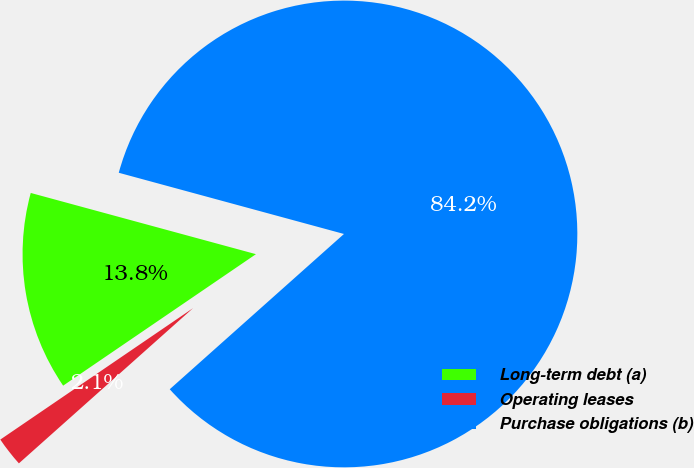Convert chart to OTSL. <chart><loc_0><loc_0><loc_500><loc_500><pie_chart><fcel>Long-term debt (a)<fcel>Operating leases<fcel>Purchase obligations (b)<nl><fcel>13.75%<fcel>2.06%<fcel>84.19%<nl></chart> 